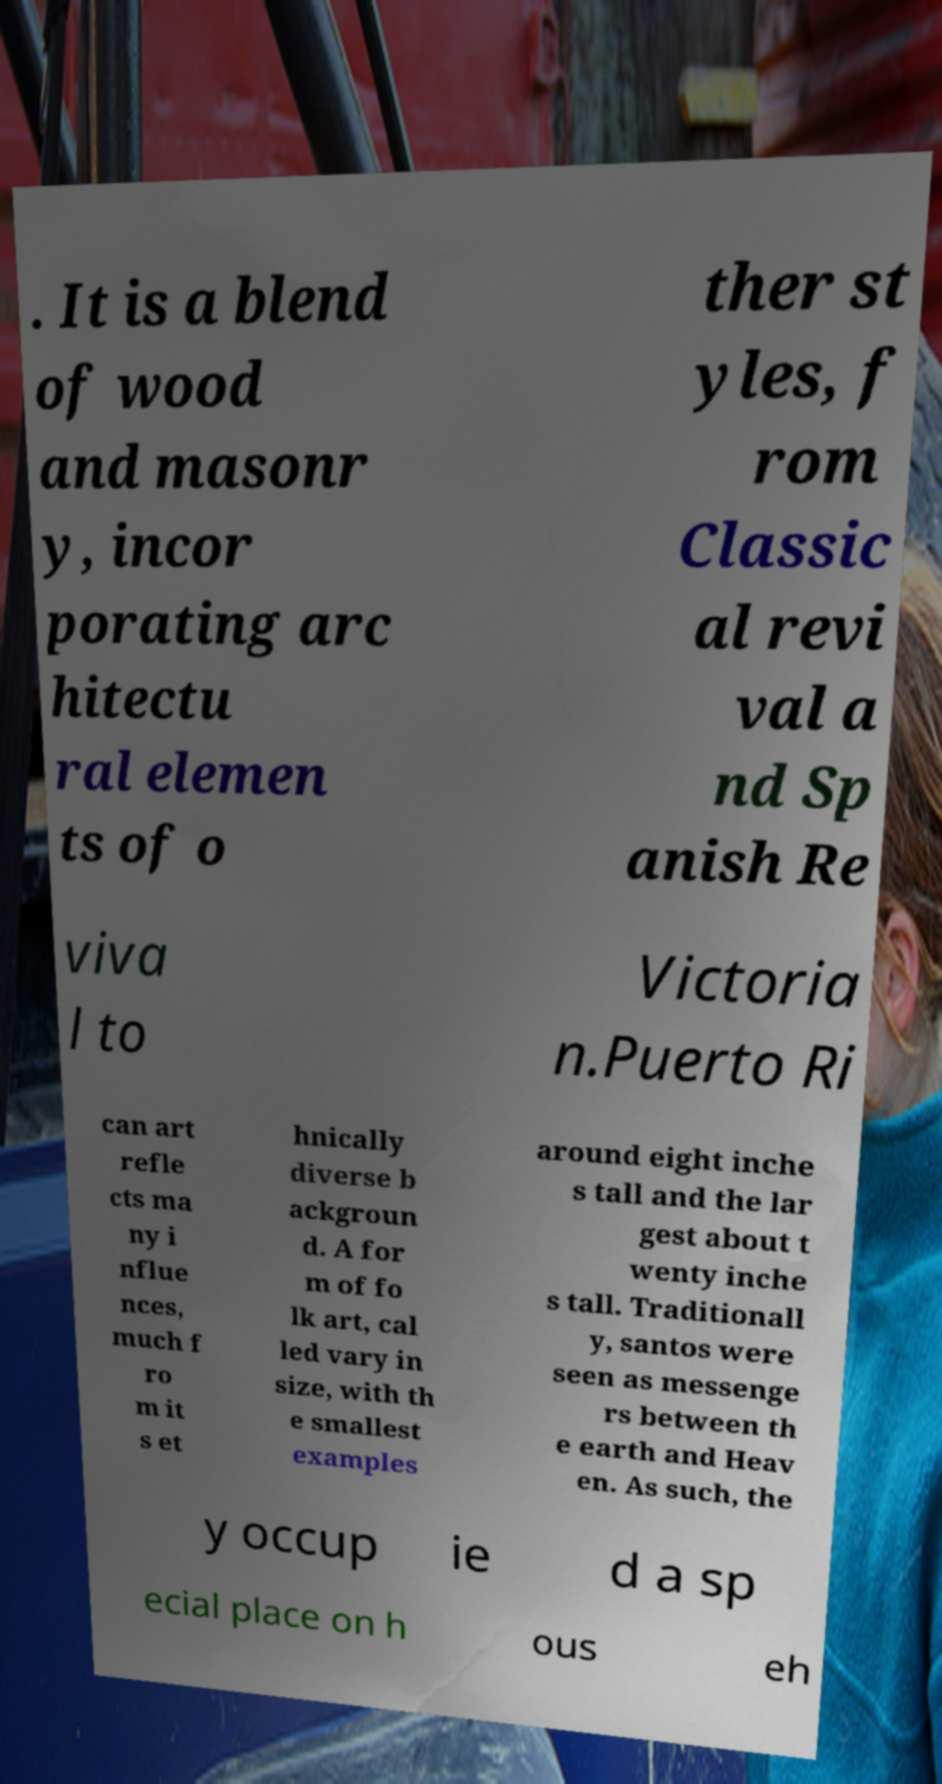There's text embedded in this image that I need extracted. Can you transcribe it verbatim? . It is a blend of wood and masonr y, incor porating arc hitectu ral elemen ts of o ther st yles, f rom Classic al revi val a nd Sp anish Re viva l to Victoria n.Puerto Ri can art refle cts ma ny i nflue nces, much f ro m it s et hnically diverse b ackgroun d. A for m of fo lk art, cal led vary in size, with th e smallest examples around eight inche s tall and the lar gest about t wenty inche s tall. Traditionall y, santos were seen as messenge rs between th e earth and Heav en. As such, the y occup ie d a sp ecial place on h ous eh 